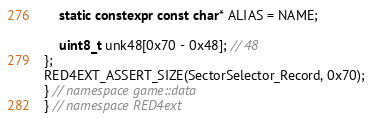<code> <loc_0><loc_0><loc_500><loc_500><_C++_>    static constexpr const char* ALIAS = NAME;

    uint8_t unk48[0x70 - 0x48]; // 48
};
RED4EXT_ASSERT_SIZE(SectorSelector_Record, 0x70);
} // namespace game::data
} // namespace RED4ext
</code> 